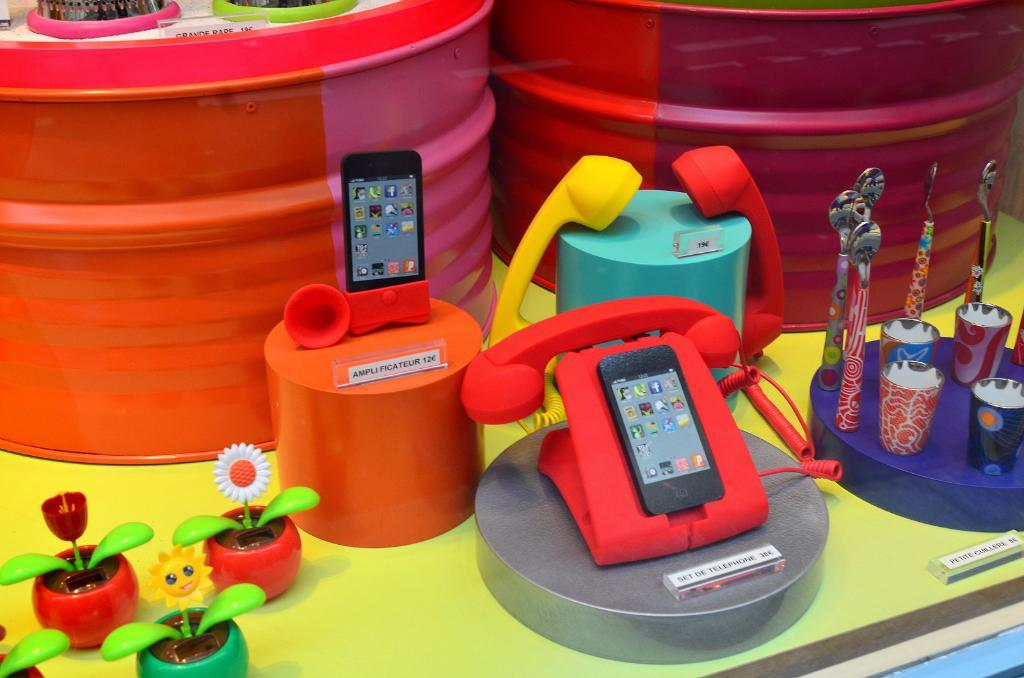What type of musical instrument can be seen in the image? There are drums in the image. What other types of objects are present in the image? There are toys like mobiles, telephones, spoons, glasses, and flower pots in the image. What is the color of the platform on which the objects are placed? The objects are placed on a green platform. What type of amusement can be seen in the image? There is no amusement park or ride present in the image; it features various objects like drums, mobiles, telephones, spoons, glasses, and flower pots. What type of behavior can be observed in the image? There is no behavior depicted in the image; it is a still image of various objects. 